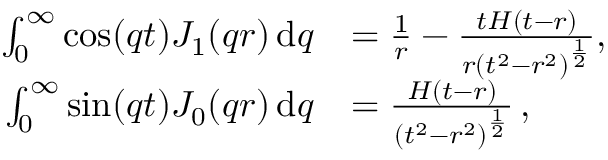Convert formula to latex. <formula><loc_0><loc_0><loc_500><loc_500>\begin{array} { r l } { \int _ { 0 } ^ { \infty } \cos ( q t ) J _ { 1 } ( q r ) \, d q } & { = \frac { 1 } { r } - \frac { t H ( t - r ) } { r \left ( t ^ { 2 } - r ^ { 2 } \right ) ^ { \frac { 1 } { 2 } } } , } \\ { \int _ { 0 } ^ { \infty } \sin ( q t ) J _ { 0 } ( q r ) \, d q } & { = \frac { H ( t - r ) } { \left ( t ^ { 2 } - r ^ { 2 } \right ) ^ { \frac { 1 } { 2 } } } \, , } \end{array}</formula> 